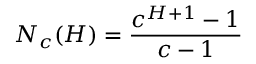<formula> <loc_0><loc_0><loc_500><loc_500>N _ { c } ( H ) = \frac { c ^ { H + 1 } - 1 } { c - 1 }</formula> 